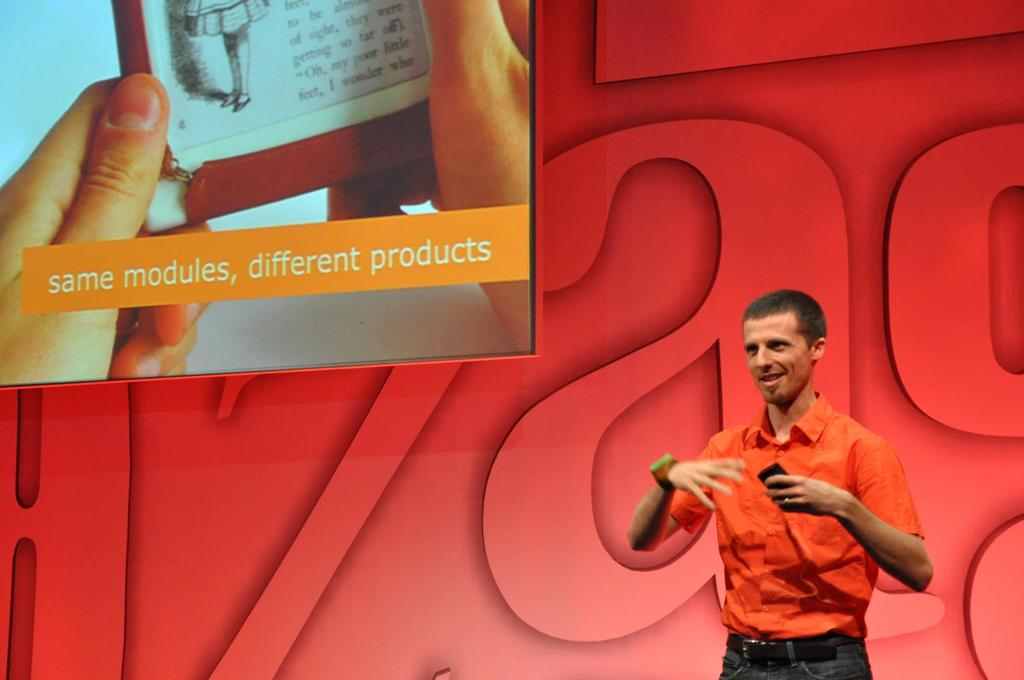What topic do you think the speaker is discussing based on the image? Based on the displayed text and the speaker's engaging posture, it's likely that the presenter is discussing innovation and versatility in technology, emphasizing how the same foundational parts can be used to create a variety of different products. 